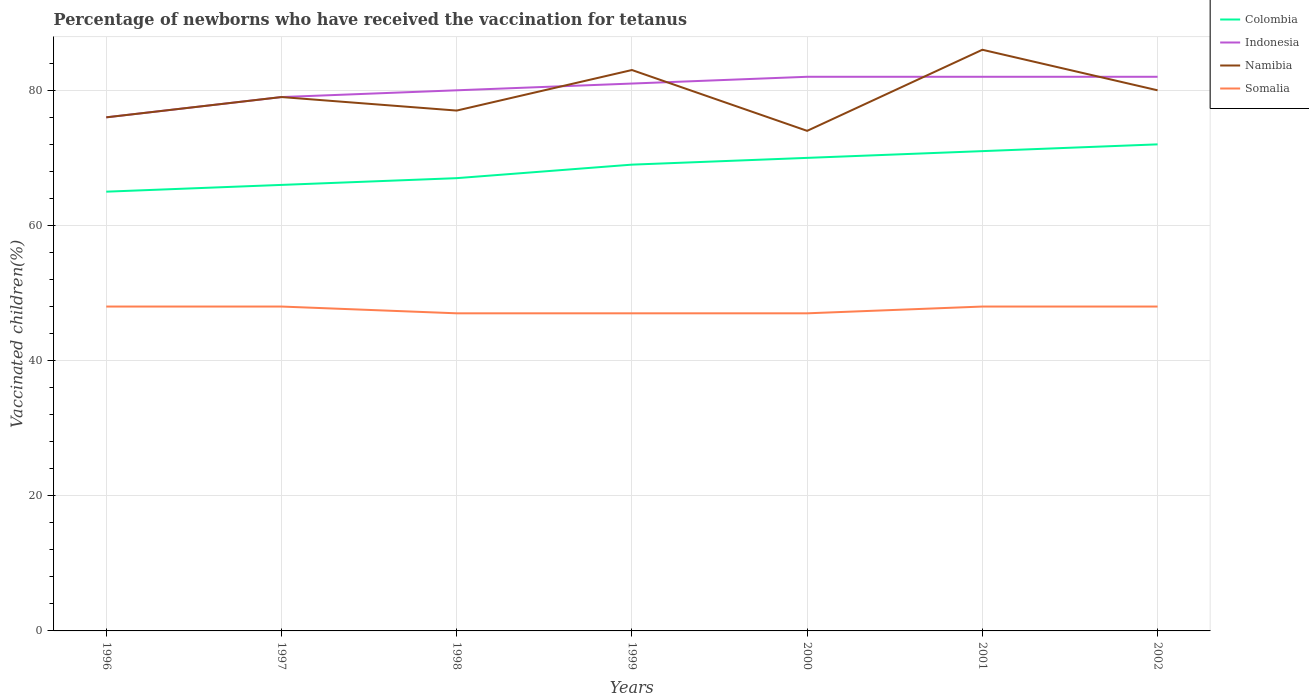How many different coloured lines are there?
Offer a very short reply. 4. Is the number of lines equal to the number of legend labels?
Your answer should be compact. Yes. In which year was the percentage of vaccinated children in Somalia maximum?
Keep it short and to the point. 1998. What is the total percentage of vaccinated children in Colombia in the graph?
Provide a short and direct response. -3. Is the percentage of vaccinated children in Indonesia strictly greater than the percentage of vaccinated children in Somalia over the years?
Give a very brief answer. No. How many lines are there?
Your answer should be compact. 4. How many years are there in the graph?
Ensure brevity in your answer.  7. What is the difference between two consecutive major ticks on the Y-axis?
Ensure brevity in your answer.  20. Does the graph contain grids?
Ensure brevity in your answer.  Yes. How many legend labels are there?
Your answer should be very brief. 4. What is the title of the graph?
Provide a short and direct response. Percentage of newborns who have received the vaccination for tetanus. What is the label or title of the Y-axis?
Make the answer very short. Vaccinated children(%). What is the Vaccinated children(%) in Colombia in 1996?
Keep it short and to the point. 65. What is the Vaccinated children(%) of Indonesia in 1996?
Keep it short and to the point. 76. What is the Vaccinated children(%) of Namibia in 1996?
Offer a terse response. 76. What is the Vaccinated children(%) of Indonesia in 1997?
Give a very brief answer. 79. What is the Vaccinated children(%) of Namibia in 1997?
Offer a very short reply. 79. What is the Vaccinated children(%) in Indonesia in 1998?
Your response must be concise. 80. What is the Vaccinated children(%) in Namibia in 1999?
Offer a very short reply. 83. What is the Vaccinated children(%) of Somalia in 2001?
Offer a terse response. 48. What is the Vaccinated children(%) of Namibia in 2002?
Ensure brevity in your answer.  80. Across all years, what is the maximum Vaccinated children(%) of Colombia?
Keep it short and to the point. 72. Across all years, what is the minimum Vaccinated children(%) of Colombia?
Give a very brief answer. 65. What is the total Vaccinated children(%) of Colombia in the graph?
Give a very brief answer. 480. What is the total Vaccinated children(%) in Indonesia in the graph?
Your answer should be compact. 562. What is the total Vaccinated children(%) of Namibia in the graph?
Make the answer very short. 555. What is the total Vaccinated children(%) in Somalia in the graph?
Your response must be concise. 333. What is the difference between the Vaccinated children(%) in Indonesia in 1996 and that in 1997?
Make the answer very short. -3. What is the difference between the Vaccinated children(%) of Colombia in 1996 and that in 1998?
Your answer should be very brief. -2. What is the difference between the Vaccinated children(%) in Indonesia in 1996 and that in 1998?
Offer a terse response. -4. What is the difference between the Vaccinated children(%) in Somalia in 1996 and that in 1998?
Give a very brief answer. 1. What is the difference between the Vaccinated children(%) in Colombia in 1996 and that in 1999?
Make the answer very short. -4. What is the difference between the Vaccinated children(%) in Indonesia in 1996 and that in 1999?
Make the answer very short. -5. What is the difference between the Vaccinated children(%) of Somalia in 1996 and that in 1999?
Your answer should be compact. 1. What is the difference between the Vaccinated children(%) in Indonesia in 1996 and that in 2000?
Offer a terse response. -6. What is the difference between the Vaccinated children(%) of Namibia in 1996 and that in 2000?
Make the answer very short. 2. What is the difference between the Vaccinated children(%) in Somalia in 1996 and that in 2000?
Provide a short and direct response. 1. What is the difference between the Vaccinated children(%) in Colombia in 1996 and that in 2001?
Your answer should be compact. -6. What is the difference between the Vaccinated children(%) of Indonesia in 1996 and that in 2002?
Offer a terse response. -6. What is the difference between the Vaccinated children(%) of Colombia in 1997 and that in 1998?
Offer a terse response. -1. What is the difference between the Vaccinated children(%) in Namibia in 1997 and that in 1998?
Make the answer very short. 2. What is the difference between the Vaccinated children(%) in Somalia in 1997 and that in 2000?
Ensure brevity in your answer.  1. What is the difference between the Vaccinated children(%) of Colombia in 1997 and that in 2001?
Your response must be concise. -5. What is the difference between the Vaccinated children(%) in Namibia in 1997 and that in 2001?
Your response must be concise. -7. What is the difference between the Vaccinated children(%) of Indonesia in 1997 and that in 2002?
Provide a succinct answer. -3. What is the difference between the Vaccinated children(%) of Namibia in 1997 and that in 2002?
Make the answer very short. -1. What is the difference between the Vaccinated children(%) in Somalia in 1997 and that in 2002?
Your answer should be compact. 0. What is the difference between the Vaccinated children(%) of Colombia in 1998 and that in 1999?
Make the answer very short. -2. What is the difference between the Vaccinated children(%) in Namibia in 1998 and that in 1999?
Make the answer very short. -6. What is the difference between the Vaccinated children(%) of Somalia in 1998 and that in 1999?
Offer a very short reply. 0. What is the difference between the Vaccinated children(%) of Indonesia in 1998 and that in 2000?
Your response must be concise. -2. What is the difference between the Vaccinated children(%) in Namibia in 1998 and that in 2000?
Your answer should be compact. 3. What is the difference between the Vaccinated children(%) in Somalia in 1998 and that in 2000?
Your response must be concise. 0. What is the difference between the Vaccinated children(%) in Indonesia in 1998 and that in 2002?
Keep it short and to the point. -2. What is the difference between the Vaccinated children(%) of Indonesia in 1999 and that in 2000?
Your answer should be compact. -1. What is the difference between the Vaccinated children(%) in Namibia in 1999 and that in 2000?
Provide a succinct answer. 9. What is the difference between the Vaccinated children(%) in Somalia in 1999 and that in 2000?
Your response must be concise. 0. What is the difference between the Vaccinated children(%) in Colombia in 1999 and that in 2001?
Your response must be concise. -2. What is the difference between the Vaccinated children(%) of Indonesia in 1999 and that in 2001?
Offer a very short reply. -1. What is the difference between the Vaccinated children(%) of Somalia in 1999 and that in 2001?
Give a very brief answer. -1. What is the difference between the Vaccinated children(%) in Somalia in 1999 and that in 2002?
Offer a terse response. -1. What is the difference between the Vaccinated children(%) in Colombia in 2000 and that in 2001?
Your answer should be compact. -1. What is the difference between the Vaccinated children(%) of Indonesia in 2000 and that in 2002?
Provide a short and direct response. 0. What is the difference between the Vaccinated children(%) of Colombia in 2001 and that in 2002?
Give a very brief answer. -1. What is the difference between the Vaccinated children(%) of Somalia in 2001 and that in 2002?
Offer a terse response. 0. What is the difference between the Vaccinated children(%) in Colombia in 1996 and the Vaccinated children(%) in Indonesia in 1997?
Give a very brief answer. -14. What is the difference between the Vaccinated children(%) in Colombia in 1996 and the Vaccinated children(%) in Namibia in 1997?
Offer a terse response. -14. What is the difference between the Vaccinated children(%) in Colombia in 1996 and the Vaccinated children(%) in Somalia in 1997?
Provide a short and direct response. 17. What is the difference between the Vaccinated children(%) of Indonesia in 1996 and the Vaccinated children(%) of Somalia in 1997?
Ensure brevity in your answer.  28. What is the difference between the Vaccinated children(%) of Namibia in 1996 and the Vaccinated children(%) of Somalia in 1997?
Provide a short and direct response. 28. What is the difference between the Vaccinated children(%) of Colombia in 1996 and the Vaccinated children(%) of Indonesia in 1998?
Offer a terse response. -15. What is the difference between the Vaccinated children(%) of Indonesia in 1996 and the Vaccinated children(%) of Namibia in 1998?
Your answer should be very brief. -1. What is the difference between the Vaccinated children(%) of Colombia in 1996 and the Vaccinated children(%) of Somalia in 1999?
Ensure brevity in your answer.  18. What is the difference between the Vaccinated children(%) of Indonesia in 1996 and the Vaccinated children(%) of Somalia in 1999?
Keep it short and to the point. 29. What is the difference between the Vaccinated children(%) in Namibia in 1996 and the Vaccinated children(%) in Somalia in 1999?
Your answer should be very brief. 29. What is the difference between the Vaccinated children(%) of Colombia in 1996 and the Vaccinated children(%) of Namibia in 2000?
Give a very brief answer. -9. What is the difference between the Vaccinated children(%) of Indonesia in 1996 and the Vaccinated children(%) of Namibia in 2000?
Your response must be concise. 2. What is the difference between the Vaccinated children(%) in Colombia in 1996 and the Vaccinated children(%) in Namibia in 2001?
Your answer should be compact. -21. What is the difference between the Vaccinated children(%) of Colombia in 1996 and the Vaccinated children(%) of Somalia in 2001?
Ensure brevity in your answer.  17. What is the difference between the Vaccinated children(%) of Indonesia in 1996 and the Vaccinated children(%) of Namibia in 2001?
Keep it short and to the point. -10. What is the difference between the Vaccinated children(%) in Indonesia in 1996 and the Vaccinated children(%) in Somalia in 2001?
Your response must be concise. 28. What is the difference between the Vaccinated children(%) of Namibia in 1996 and the Vaccinated children(%) of Somalia in 2001?
Offer a very short reply. 28. What is the difference between the Vaccinated children(%) of Colombia in 1996 and the Vaccinated children(%) of Somalia in 2002?
Provide a succinct answer. 17. What is the difference between the Vaccinated children(%) in Indonesia in 1996 and the Vaccinated children(%) in Namibia in 2002?
Your answer should be compact. -4. What is the difference between the Vaccinated children(%) in Namibia in 1996 and the Vaccinated children(%) in Somalia in 2002?
Give a very brief answer. 28. What is the difference between the Vaccinated children(%) of Colombia in 1997 and the Vaccinated children(%) of Somalia in 1998?
Provide a short and direct response. 19. What is the difference between the Vaccinated children(%) of Indonesia in 1997 and the Vaccinated children(%) of Namibia in 1998?
Your response must be concise. 2. What is the difference between the Vaccinated children(%) of Colombia in 1997 and the Vaccinated children(%) of Namibia in 1999?
Offer a terse response. -17. What is the difference between the Vaccinated children(%) of Colombia in 1997 and the Vaccinated children(%) of Somalia in 1999?
Your response must be concise. 19. What is the difference between the Vaccinated children(%) of Indonesia in 1997 and the Vaccinated children(%) of Namibia in 1999?
Give a very brief answer. -4. What is the difference between the Vaccinated children(%) of Namibia in 1997 and the Vaccinated children(%) of Somalia in 1999?
Keep it short and to the point. 32. What is the difference between the Vaccinated children(%) of Colombia in 1997 and the Vaccinated children(%) of Namibia in 2000?
Provide a succinct answer. -8. What is the difference between the Vaccinated children(%) in Colombia in 1997 and the Vaccinated children(%) in Somalia in 2000?
Keep it short and to the point. 19. What is the difference between the Vaccinated children(%) in Indonesia in 1997 and the Vaccinated children(%) in Namibia in 2000?
Give a very brief answer. 5. What is the difference between the Vaccinated children(%) in Indonesia in 1997 and the Vaccinated children(%) in Somalia in 2000?
Provide a short and direct response. 32. What is the difference between the Vaccinated children(%) of Colombia in 1997 and the Vaccinated children(%) of Indonesia in 2001?
Keep it short and to the point. -16. What is the difference between the Vaccinated children(%) in Colombia in 1997 and the Vaccinated children(%) in Namibia in 2001?
Your response must be concise. -20. What is the difference between the Vaccinated children(%) in Colombia in 1997 and the Vaccinated children(%) in Somalia in 2001?
Your answer should be compact. 18. What is the difference between the Vaccinated children(%) in Namibia in 1997 and the Vaccinated children(%) in Somalia in 2001?
Your answer should be compact. 31. What is the difference between the Vaccinated children(%) in Colombia in 1997 and the Vaccinated children(%) in Indonesia in 2002?
Your answer should be compact. -16. What is the difference between the Vaccinated children(%) in Colombia in 1997 and the Vaccinated children(%) in Namibia in 2002?
Offer a terse response. -14. What is the difference between the Vaccinated children(%) of Colombia in 1997 and the Vaccinated children(%) of Somalia in 2002?
Ensure brevity in your answer.  18. What is the difference between the Vaccinated children(%) of Namibia in 1997 and the Vaccinated children(%) of Somalia in 2002?
Offer a very short reply. 31. What is the difference between the Vaccinated children(%) in Indonesia in 1998 and the Vaccinated children(%) in Namibia in 1999?
Offer a very short reply. -3. What is the difference between the Vaccinated children(%) in Indonesia in 1998 and the Vaccinated children(%) in Somalia in 1999?
Provide a succinct answer. 33. What is the difference between the Vaccinated children(%) of Indonesia in 1998 and the Vaccinated children(%) of Somalia in 2000?
Give a very brief answer. 33. What is the difference between the Vaccinated children(%) of Namibia in 1998 and the Vaccinated children(%) of Somalia in 2000?
Give a very brief answer. 30. What is the difference between the Vaccinated children(%) in Colombia in 1998 and the Vaccinated children(%) in Somalia in 2001?
Your answer should be compact. 19. What is the difference between the Vaccinated children(%) of Indonesia in 1998 and the Vaccinated children(%) of Somalia in 2001?
Make the answer very short. 32. What is the difference between the Vaccinated children(%) in Namibia in 1998 and the Vaccinated children(%) in Somalia in 2001?
Your response must be concise. 29. What is the difference between the Vaccinated children(%) in Colombia in 1998 and the Vaccinated children(%) in Indonesia in 2002?
Give a very brief answer. -15. What is the difference between the Vaccinated children(%) of Colombia in 1998 and the Vaccinated children(%) of Namibia in 2002?
Offer a very short reply. -13. What is the difference between the Vaccinated children(%) in Colombia in 1998 and the Vaccinated children(%) in Somalia in 2002?
Give a very brief answer. 19. What is the difference between the Vaccinated children(%) in Namibia in 1998 and the Vaccinated children(%) in Somalia in 2002?
Offer a very short reply. 29. What is the difference between the Vaccinated children(%) of Colombia in 1999 and the Vaccinated children(%) of Somalia in 2000?
Keep it short and to the point. 22. What is the difference between the Vaccinated children(%) of Indonesia in 1999 and the Vaccinated children(%) of Somalia in 2000?
Make the answer very short. 34. What is the difference between the Vaccinated children(%) in Namibia in 1999 and the Vaccinated children(%) in Somalia in 2000?
Offer a terse response. 36. What is the difference between the Vaccinated children(%) in Colombia in 1999 and the Vaccinated children(%) in Indonesia in 2001?
Your response must be concise. -13. What is the difference between the Vaccinated children(%) in Colombia in 1999 and the Vaccinated children(%) in Somalia in 2001?
Offer a very short reply. 21. What is the difference between the Vaccinated children(%) in Indonesia in 1999 and the Vaccinated children(%) in Somalia in 2001?
Your response must be concise. 33. What is the difference between the Vaccinated children(%) of Namibia in 1999 and the Vaccinated children(%) of Somalia in 2001?
Make the answer very short. 35. What is the difference between the Vaccinated children(%) of Colombia in 1999 and the Vaccinated children(%) of Indonesia in 2002?
Make the answer very short. -13. What is the difference between the Vaccinated children(%) of Colombia in 1999 and the Vaccinated children(%) of Namibia in 2002?
Your answer should be very brief. -11. What is the difference between the Vaccinated children(%) in Indonesia in 2000 and the Vaccinated children(%) in Namibia in 2001?
Keep it short and to the point. -4. What is the difference between the Vaccinated children(%) of Colombia in 2000 and the Vaccinated children(%) of Indonesia in 2002?
Your answer should be compact. -12. What is the difference between the Vaccinated children(%) in Colombia in 2000 and the Vaccinated children(%) in Namibia in 2002?
Offer a terse response. -10. What is the difference between the Vaccinated children(%) in Indonesia in 2000 and the Vaccinated children(%) in Namibia in 2002?
Offer a very short reply. 2. What is the difference between the Vaccinated children(%) in Namibia in 2000 and the Vaccinated children(%) in Somalia in 2002?
Offer a very short reply. 26. What is the difference between the Vaccinated children(%) in Colombia in 2001 and the Vaccinated children(%) in Namibia in 2002?
Offer a very short reply. -9. What is the difference between the Vaccinated children(%) of Colombia in 2001 and the Vaccinated children(%) of Somalia in 2002?
Provide a short and direct response. 23. What is the difference between the Vaccinated children(%) in Namibia in 2001 and the Vaccinated children(%) in Somalia in 2002?
Make the answer very short. 38. What is the average Vaccinated children(%) of Colombia per year?
Your response must be concise. 68.57. What is the average Vaccinated children(%) in Indonesia per year?
Give a very brief answer. 80.29. What is the average Vaccinated children(%) of Namibia per year?
Your response must be concise. 79.29. What is the average Vaccinated children(%) of Somalia per year?
Ensure brevity in your answer.  47.57. In the year 1996, what is the difference between the Vaccinated children(%) in Colombia and Vaccinated children(%) in Namibia?
Provide a short and direct response. -11. In the year 1996, what is the difference between the Vaccinated children(%) of Indonesia and Vaccinated children(%) of Namibia?
Your response must be concise. 0. In the year 1996, what is the difference between the Vaccinated children(%) of Indonesia and Vaccinated children(%) of Somalia?
Offer a terse response. 28. In the year 1997, what is the difference between the Vaccinated children(%) in Colombia and Vaccinated children(%) in Indonesia?
Keep it short and to the point. -13. In the year 1997, what is the difference between the Vaccinated children(%) in Indonesia and Vaccinated children(%) in Namibia?
Ensure brevity in your answer.  0. In the year 1997, what is the difference between the Vaccinated children(%) in Indonesia and Vaccinated children(%) in Somalia?
Your answer should be compact. 31. In the year 1997, what is the difference between the Vaccinated children(%) in Namibia and Vaccinated children(%) in Somalia?
Your response must be concise. 31. In the year 1998, what is the difference between the Vaccinated children(%) of Colombia and Vaccinated children(%) of Indonesia?
Make the answer very short. -13. In the year 1998, what is the difference between the Vaccinated children(%) of Colombia and Vaccinated children(%) of Somalia?
Ensure brevity in your answer.  20. In the year 1998, what is the difference between the Vaccinated children(%) in Indonesia and Vaccinated children(%) in Somalia?
Your answer should be very brief. 33. In the year 1998, what is the difference between the Vaccinated children(%) in Namibia and Vaccinated children(%) in Somalia?
Give a very brief answer. 30. In the year 1999, what is the difference between the Vaccinated children(%) of Indonesia and Vaccinated children(%) of Namibia?
Offer a terse response. -2. In the year 1999, what is the difference between the Vaccinated children(%) in Indonesia and Vaccinated children(%) in Somalia?
Offer a terse response. 34. In the year 2000, what is the difference between the Vaccinated children(%) of Colombia and Vaccinated children(%) of Namibia?
Your answer should be very brief. -4. In the year 2000, what is the difference between the Vaccinated children(%) in Colombia and Vaccinated children(%) in Somalia?
Your answer should be compact. 23. In the year 2000, what is the difference between the Vaccinated children(%) of Indonesia and Vaccinated children(%) of Somalia?
Your answer should be very brief. 35. In the year 2001, what is the difference between the Vaccinated children(%) in Colombia and Vaccinated children(%) in Somalia?
Make the answer very short. 23. In the year 2002, what is the difference between the Vaccinated children(%) of Colombia and Vaccinated children(%) of Indonesia?
Give a very brief answer. -10. In the year 2002, what is the difference between the Vaccinated children(%) of Colombia and Vaccinated children(%) of Namibia?
Ensure brevity in your answer.  -8. In the year 2002, what is the difference between the Vaccinated children(%) in Indonesia and Vaccinated children(%) in Namibia?
Ensure brevity in your answer.  2. In the year 2002, what is the difference between the Vaccinated children(%) of Indonesia and Vaccinated children(%) of Somalia?
Make the answer very short. 34. In the year 2002, what is the difference between the Vaccinated children(%) in Namibia and Vaccinated children(%) in Somalia?
Give a very brief answer. 32. What is the ratio of the Vaccinated children(%) of Namibia in 1996 to that in 1997?
Make the answer very short. 0.96. What is the ratio of the Vaccinated children(%) of Somalia in 1996 to that in 1997?
Your answer should be compact. 1. What is the ratio of the Vaccinated children(%) in Colombia in 1996 to that in 1998?
Your answer should be very brief. 0.97. What is the ratio of the Vaccinated children(%) in Indonesia in 1996 to that in 1998?
Provide a short and direct response. 0.95. What is the ratio of the Vaccinated children(%) of Somalia in 1996 to that in 1998?
Your answer should be very brief. 1.02. What is the ratio of the Vaccinated children(%) in Colombia in 1996 to that in 1999?
Offer a very short reply. 0.94. What is the ratio of the Vaccinated children(%) of Indonesia in 1996 to that in 1999?
Your answer should be very brief. 0.94. What is the ratio of the Vaccinated children(%) in Namibia in 1996 to that in 1999?
Offer a very short reply. 0.92. What is the ratio of the Vaccinated children(%) in Somalia in 1996 to that in 1999?
Ensure brevity in your answer.  1.02. What is the ratio of the Vaccinated children(%) of Colombia in 1996 to that in 2000?
Make the answer very short. 0.93. What is the ratio of the Vaccinated children(%) of Indonesia in 1996 to that in 2000?
Provide a short and direct response. 0.93. What is the ratio of the Vaccinated children(%) of Namibia in 1996 to that in 2000?
Offer a terse response. 1.03. What is the ratio of the Vaccinated children(%) in Somalia in 1996 to that in 2000?
Provide a succinct answer. 1.02. What is the ratio of the Vaccinated children(%) in Colombia in 1996 to that in 2001?
Keep it short and to the point. 0.92. What is the ratio of the Vaccinated children(%) of Indonesia in 1996 to that in 2001?
Provide a short and direct response. 0.93. What is the ratio of the Vaccinated children(%) of Namibia in 1996 to that in 2001?
Provide a succinct answer. 0.88. What is the ratio of the Vaccinated children(%) of Somalia in 1996 to that in 2001?
Provide a short and direct response. 1. What is the ratio of the Vaccinated children(%) of Colombia in 1996 to that in 2002?
Keep it short and to the point. 0.9. What is the ratio of the Vaccinated children(%) in Indonesia in 1996 to that in 2002?
Give a very brief answer. 0.93. What is the ratio of the Vaccinated children(%) in Namibia in 1996 to that in 2002?
Make the answer very short. 0.95. What is the ratio of the Vaccinated children(%) of Colombia in 1997 to that in 1998?
Keep it short and to the point. 0.99. What is the ratio of the Vaccinated children(%) in Indonesia in 1997 to that in 1998?
Your answer should be very brief. 0.99. What is the ratio of the Vaccinated children(%) in Somalia in 1997 to that in 1998?
Provide a short and direct response. 1.02. What is the ratio of the Vaccinated children(%) of Colombia in 1997 to that in 1999?
Keep it short and to the point. 0.96. What is the ratio of the Vaccinated children(%) in Indonesia in 1997 to that in 1999?
Keep it short and to the point. 0.98. What is the ratio of the Vaccinated children(%) of Namibia in 1997 to that in 1999?
Your answer should be compact. 0.95. What is the ratio of the Vaccinated children(%) in Somalia in 1997 to that in 1999?
Ensure brevity in your answer.  1.02. What is the ratio of the Vaccinated children(%) of Colombia in 1997 to that in 2000?
Make the answer very short. 0.94. What is the ratio of the Vaccinated children(%) of Indonesia in 1997 to that in 2000?
Ensure brevity in your answer.  0.96. What is the ratio of the Vaccinated children(%) of Namibia in 1997 to that in 2000?
Give a very brief answer. 1.07. What is the ratio of the Vaccinated children(%) in Somalia in 1997 to that in 2000?
Provide a succinct answer. 1.02. What is the ratio of the Vaccinated children(%) in Colombia in 1997 to that in 2001?
Offer a very short reply. 0.93. What is the ratio of the Vaccinated children(%) in Indonesia in 1997 to that in 2001?
Make the answer very short. 0.96. What is the ratio of the Vaccinated children(%) in Namibia in 1997 to that in 2001?
Provide a short and direct response. 0.92. What is the ratio of the Vaccinated children(%) in Somalia in 1997 to that in 2001?
Provide a succinct answer. 1. What is the ratio of the Vaccinated children(%) of Colombia in 1997 to that in 2002?
Provide a succinct answer. 0.92. What is the ratio of the Vaccinated children(%) of Indonesia in 1997 to that in 2002?
Give a very brief answer. 0.96. What is the ratio of the Vaccinated children(%) of Namibia in 1997 to that in 2002?
Your response must be concise. 0.99. What is the ratio of the Vaccinated children(%) in Somalia in 1997 to that in 2002?
Your response must be concise. 1. What is the ratio of the Vaccinated children(%) in Colombia in 1998 to that in 1999?
Your answer should be compact. 0.97. What is the ratio of the Vaccinated children(%) in Indonesia in 1998 to that in 1999?
Your response must be concise. 0.99. What is the ratio of the Vaccinated children(%) in Namibia in 1998 to that in 1999?
Your answer should be very brief. 0.93. What is the ratio of the Vaccinated children(%) in Colombia in 1998 to that in 2000?
Your response must be concise. 0.96. What is the ratio of the Vaccinated children(%) in Indonesia in 1998 to that in 2000?
Your answer should be compact. 0.98. What is the ratio of the Vaccinated children(%) of Namibia in 1998 to that in 2000?
Offer a very short reply. 1.04. What is the ratio of the Vaccinated children(%) in Somalia in 1998 to that in 2000?
Offer a terse response. 1. What is the ratio of the Vaccinated children(%) of Colombia in 1998 to that in 2001?
Keep it short and to the point. 0.94. What is the ratio of the Vaccinated children(%) in Indonesia in 1998 to that in 2001?
Your response must be concise. 0.98. What is the ratio of the Vaccinated children(%) in Namibia in 1998 to that in 2001?
Your response must be concise. 0.9. What is the ratio of the Vaccinated children(%) in Somalia in 1998 to that in 2001?
Your response must be concise. 0.98. What is the ratio of the Vaccinated children(%) in Colombia in 1998 to that in 2002?
Offer a very short reply. 0.93. What is the ratio of the Vaccinated children(%) of Indonesia in 1998 to that in 2002?
Keep it short and to the point. 0.98. What is the ratio of the Vaccinated children(%) of Namibia in 1998 to that in 2002?
Ensure brevity in your answer.  0.96. What is the ratio of the Vaccinated children(%) in Somalia in 1998 to that in 2002?
Make the answer very short. 0.98. What is the ratio of the Vaccinated children(%) in Colombia in 1999 to that in 2000?
Make the answer very short. 0.99. What is the ratio of the Vaccinated children(%) in Indonesia in 1999 to that in 2000?
Your answer should be compact. 0.99. What is the ratio of the Vaccinated children(%) in Namibia in 1999 to that in 2000?
Your answer should be compact. 1.12. What is the ratio of the Vaccinated children(%) of Somalia in 1999 to that in 2000?
Provide a short and direct response. 1. What is the ratio of the Vaccinated children(%) of Colombia in 1999 to that in 2001?
Keep it short and to the point. 0.97. What is the ratio of the Vaccinated children(%) in Indonesia in 1999 to that in 2001?
Your answer should be very brief. 0.99. What is the ratio of the Vaccinated children(%) in Namibia in 1999 to that in 2001?
Offer a very short reply. 0.97. What is the ratio of the Vaccinated children(%) of Somalia in 1999 to that in 2001?
Ensure brevity in your answer.  0.98. What is the ratio of the Vaccinated children(%) of Indonesia in 1999 to that in 2002?
Your answer should be very brief. 0.99. What is the ratio of the Vaccinated children(%) of Namibia in 1999 to that in 2002?
Give a very brief answer. 1.04. What is the ratio of the Vaccinated children(%) of Somalia in 1999 to that in 2002?
Your answer should be very brief. 0.98. What is the ratio of the Vaccinated children(%) in Colombia in 2000 to that in 2001?
Your answer should be compact. 0.99. What is the ratio of the Vaccinated children(%) in Namibia in 2000 to that in 2001?
Make the answer very short. 0.86. What is the ratio of the Vaccinated children(%) of Somalia in 2000 to that in 2001?
Your response must be concise. 0.98. What is the ratio of the Vaccinated children(%) in Colombia in 2000 to that in 2002?
Make the answer very short. 0.97. What is the ratio of the Vaccinated children(%) of Namibia in 2000 to that in 2002?
Give a very brief answer. 0.93. What is the ratio of the Vaccinated children(%) of Somalia in 2000 to that in 2002?
Give a very brief answer. 0.98. What is the ratio of the Vaccinated children(%) of Colombia in 2001 to that in 2002?
Ensure brevity in your answer.  0.99. What is the ratio of the Vaccinated children(%) in Indonesia in 2001 to that in 2002?
Your answer should be very brief. 1. What is the ratio of the Vaccinated children(%) in Namibia in 2001 to that in 2002?
Give a very brief answer. 1.07. What is the difference between the highest and the second highest Vaccinated children(%) of Indonesia?
Provide a short and direct response. 0. What is the difference between the highest and the lowest Vaccinated children(%) in Somalia?
Make the answer very short. 1. 